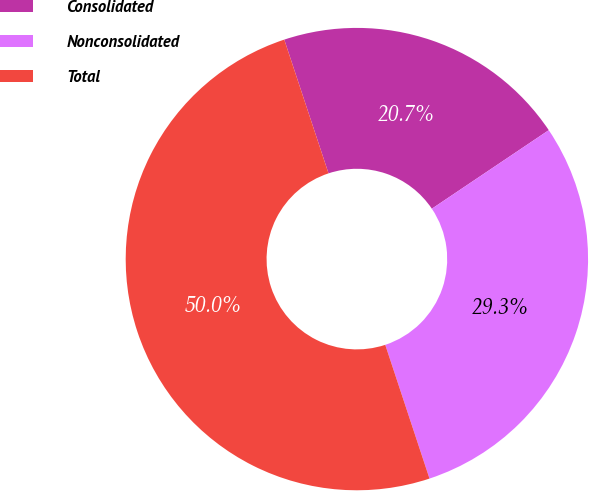Convert chart to OTSL. <chart><loc_0><loc_0><loc_500><loc_500><pie_chart><fcel>Consolidated<fcel>Nonconsolidated<fcel>Total<nl><fcel>20.67%<fcel>29.33%<fcel>50.0%<nl></chart> 